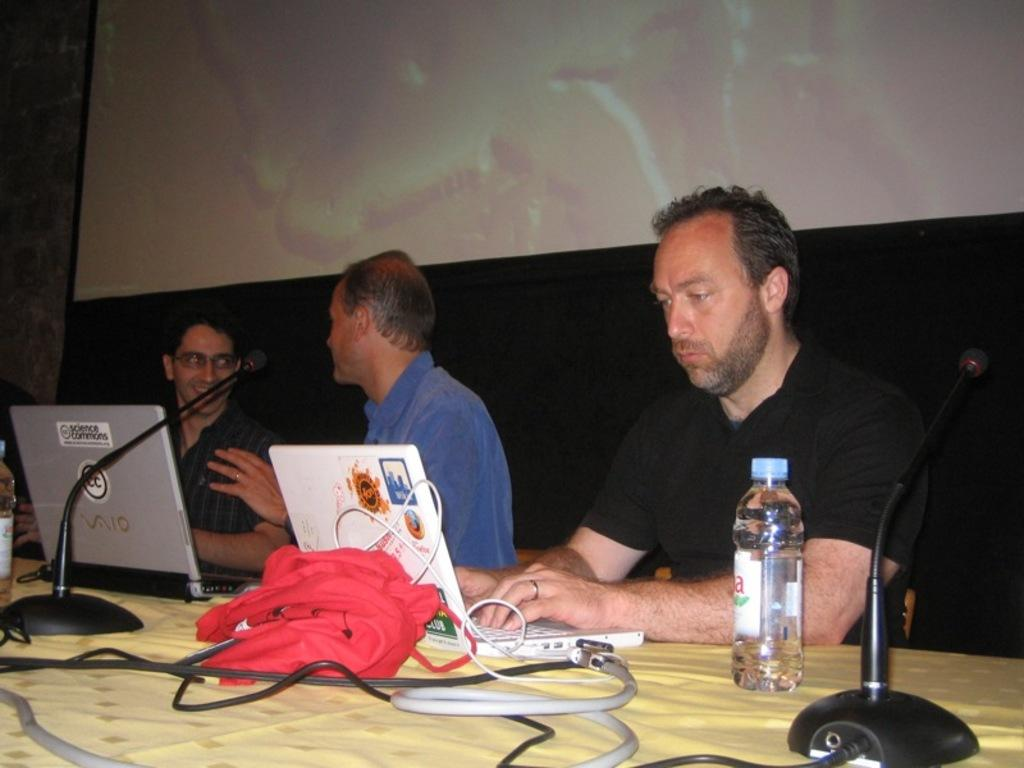What are the people in the image doing? The persons sitting behind the table are likely working or participating in a meeting, as laptops are present on the table. What objects can be seen on the table? There are laptops, bottles, microphones, wires, and a cloth on the table. What is the purpose of the microphones on the table? The microphones on the table may be used for recording audio or amplifying sound during a presentation or discussion. What is the cloth on the table used for? The cloth on the table may be used to protect the table surface or to provide a clean surface for placing objects. What is visible at the back of the scene? There is a screen at the back of the scene, which may be used for displaying information or presentations. Who is the owner of the list in the image? There is no list present in the image, so it is not possible to determine the owner. What type of hose is connected to the bottles on the table? There is no hose connected to the bottles on the table in the image. 